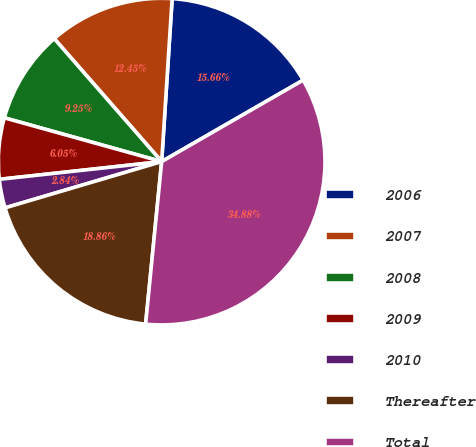Convert chart. <chart><loc_0><loc_0><loc_500><loc_500><pie_chart><fcel>2006<fcel>2007<fcel>2008<fcel>2009<fcel>2010<fcel>Thereafter<fcel>Total<nl><fcel>15.66%<fcel>12.45%<fcel>9.25%<fcel>6.05%<fcel>2.84%<fcel>18.86%<fcel>34.88%<nl></chart> 